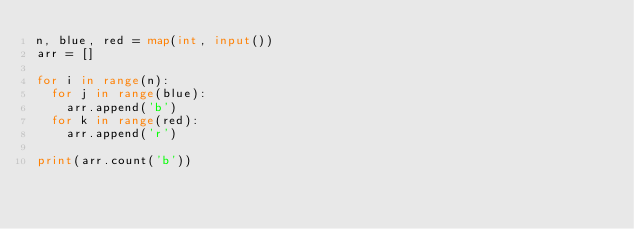Convert code to text. <code><loc_0><loc_0><loc_500><loc_500><_Python_>n, blue, red = map(int, input())
arr = []

for i in range(n):
  for j in range(blue):
    arr.append('b')
  for k in range(red):
    arr.append('r')

print(arr.count('b'))
               </code> 